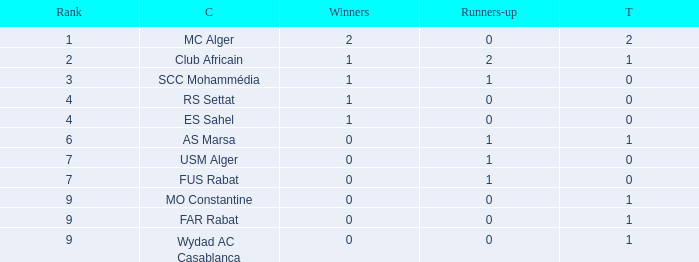How many Winners have a Third of 1, and Runners-up smaller than 0? 0.0. Would you be able to parse every entry in this table? {'header': ['Rank', 'C', 'Winners', 'Runners-up', 'T'], 'rows': [['1', 'MC Alger', '2', '0', '2'], ['2', 'Club Africain', '1', '2', '1'], ['3', 'SCC Mohammédia', '1', '1', '0'], ['4', 'RS Settat', '1', '0', '0'], ['4', 'ES Sahel', '1', '0', '0'], ['6', 'AS Marsa', '0', '1', '1'], ['7', 'USM Alger', '0', '1', '0'], ['7', 'FUS Rabat', '0', '1', '0'], ['9', 'MO Constantine', '0', '0', '1'], ['9', 'FAR Rabat', '0', '0', '1'], ['9', 'Wydad AC Casablanca', '0', '0', '1']]} 